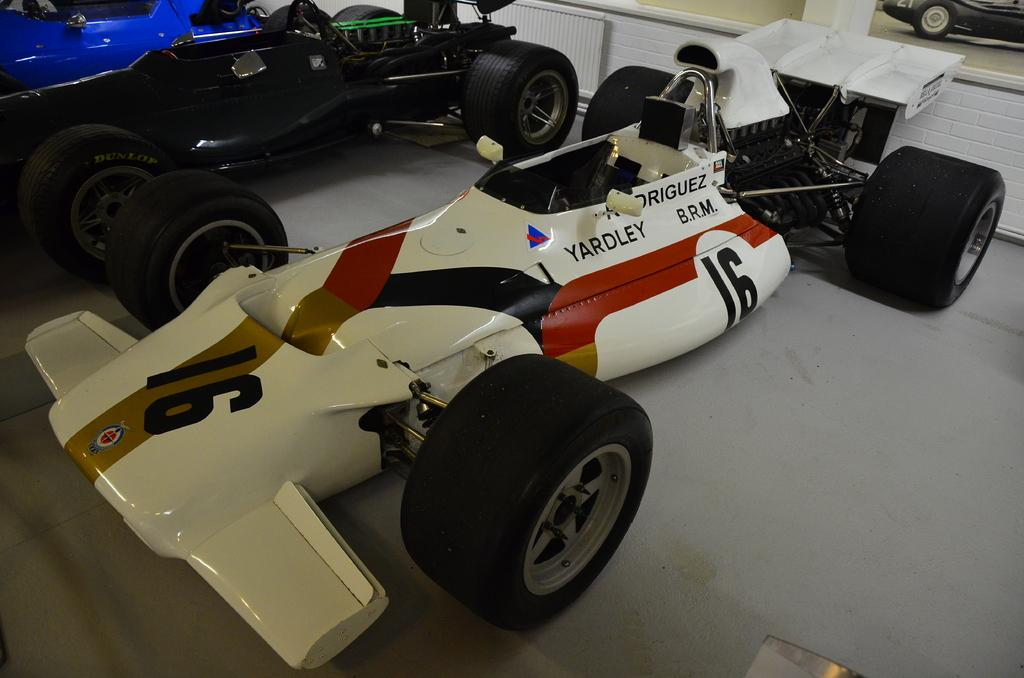What type of vehicles are present in the image? There are cars in the image. Can you describe the colors of the cars? The cars are white, black, and blue in color. How many cakes are displayed on the hood of the blue car in the image? There are no cakes present in the image; it only features cars of different colors. 